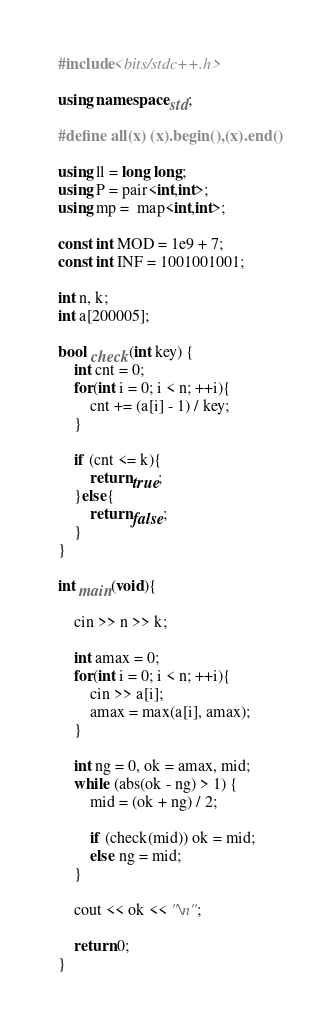<code> <loc_0><loc_0><loc_500><loc_500><_C++_>#include<bits/stdc++.h>

using namespace std;

#define all(x) (x).begin(),(x).end()

using ll = long long;
using P = pair<int,int>;
using mp =  map<int,int>;

const int MOD = 1e9 + 7;
const int INF = 1001001001;

int n, k;
int a[200005];

bool check(int key) {
    int cnt = 0;
    for(int i = 0; i < n; ++i){
        cnt += (a[i] - 1) / key;
    }

    if (cnt <= k){
        return true;
    }else{
        return false;
    }
}

int main(void){

    cin >> n >> k;

    int amax = 0;
    for(int i = 0; i < n; ++i){
        cin >> a[i];
        amax = max(a[i], amax);
    }

    int ng = 0, ok = amax, mid;
    while (abs(ok - ng) > 1) {
        mid = (ok + ng) / 2;

        if (check(mid)) ok = mid;
        else ng = mid;
    }

    cout << ok << "\n";

    return 0;
}
</code> 